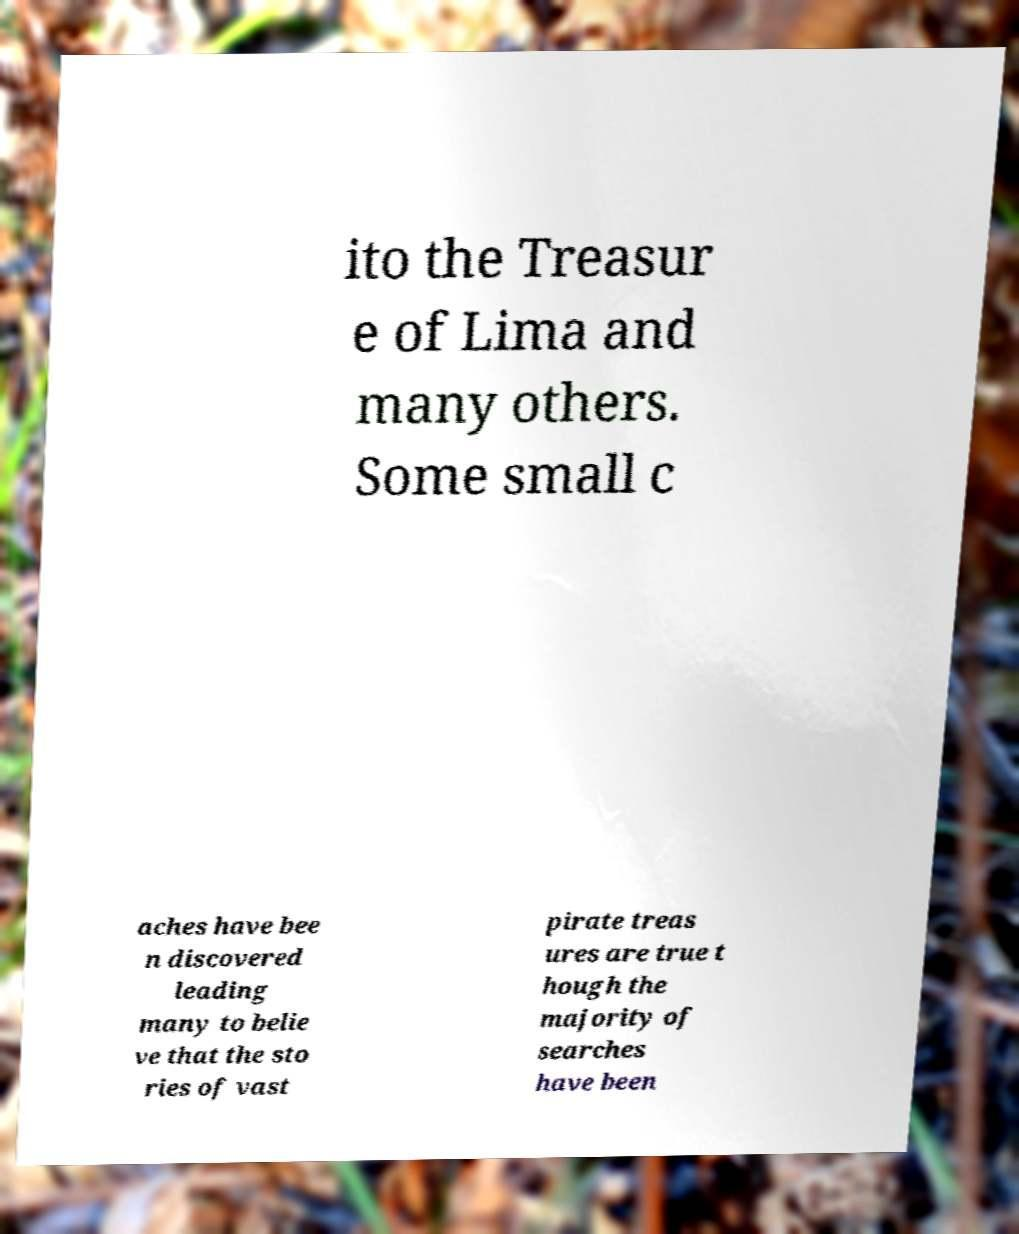Can you read and provide the text displayed in the image?This photo seems to have some interesting text. Can you extract and type it out for me? ito the Treasur e of Lima and many others. Some small c aches have bee n discovered leading many to belie ve that the sto ries of vast pirate treas ures are true t hough the majority of searches have been 